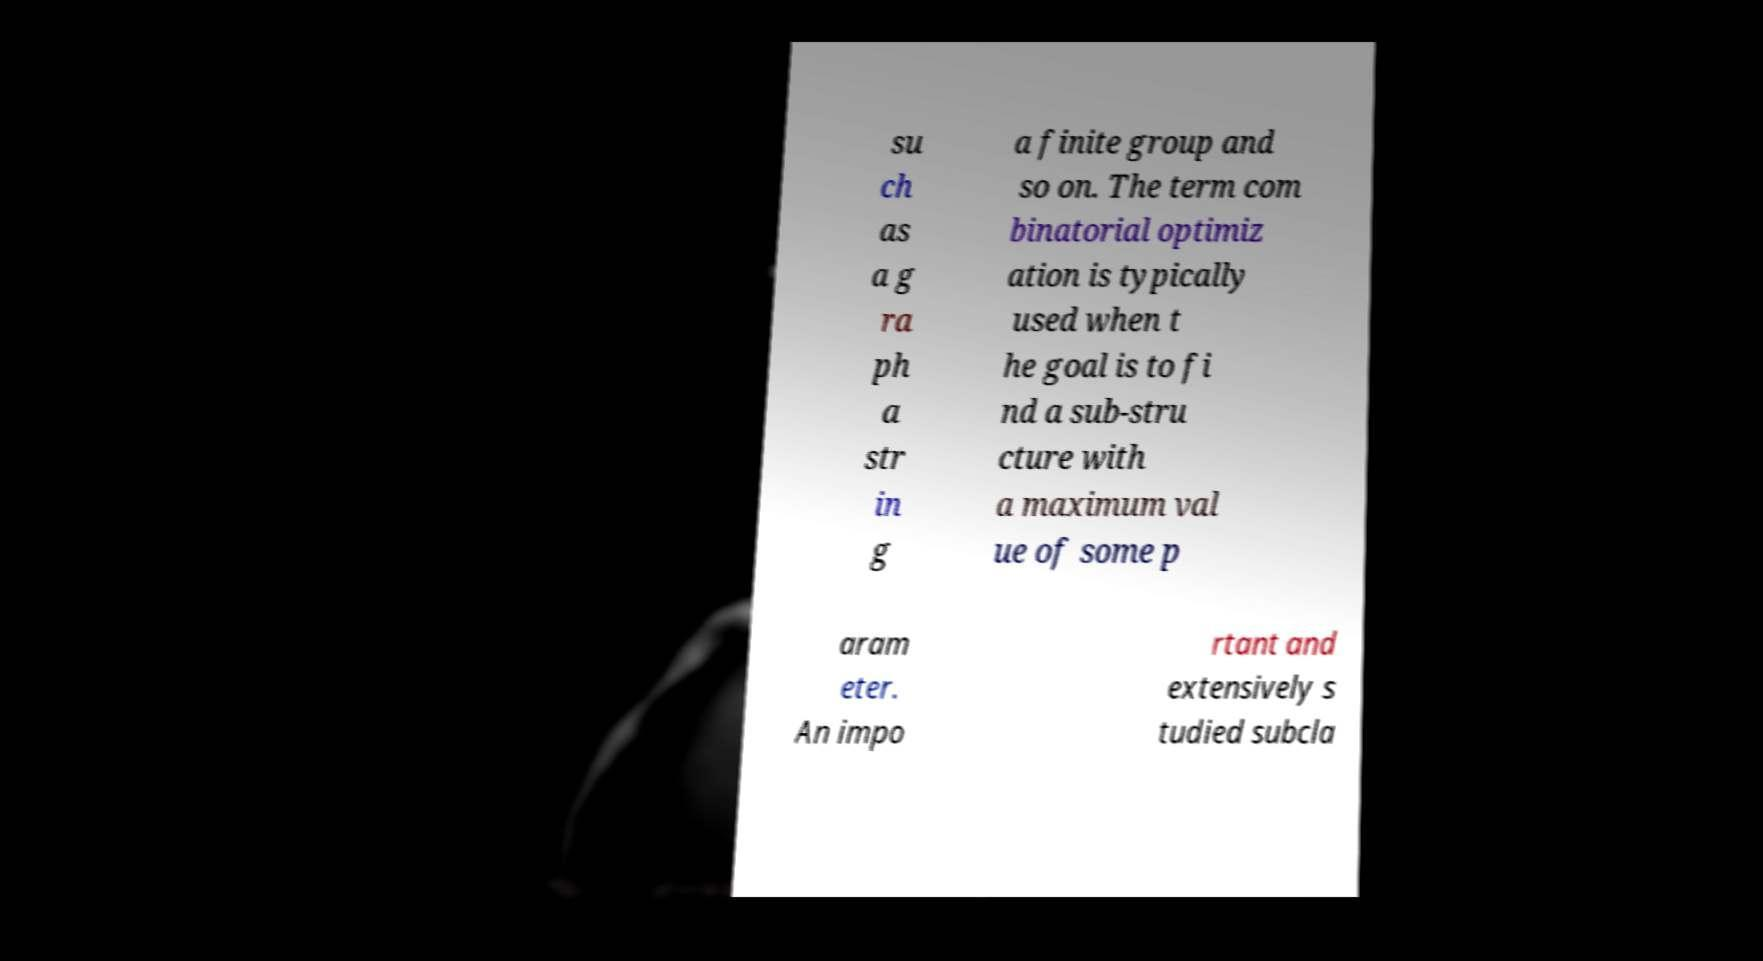I need the written content from this picture converted into text. Can you do that? su ch as a g ra ph a str in g a finite group and so on. The term com binatorial optimiz ation is typically used when t he goal is to fi nd a sub-stru cture with a maximum val ue of some p aram eter. An impo rtant and extensively s tudied subcla 